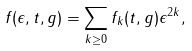<formula> <loc_0><loc_0><loc_500><loc_500>f ( \epsilon , t , g ) = \sum _ { k \geq 0 } f _ { k } ( t , g ) \epsilon ^ { 2 k } ,</formula> 